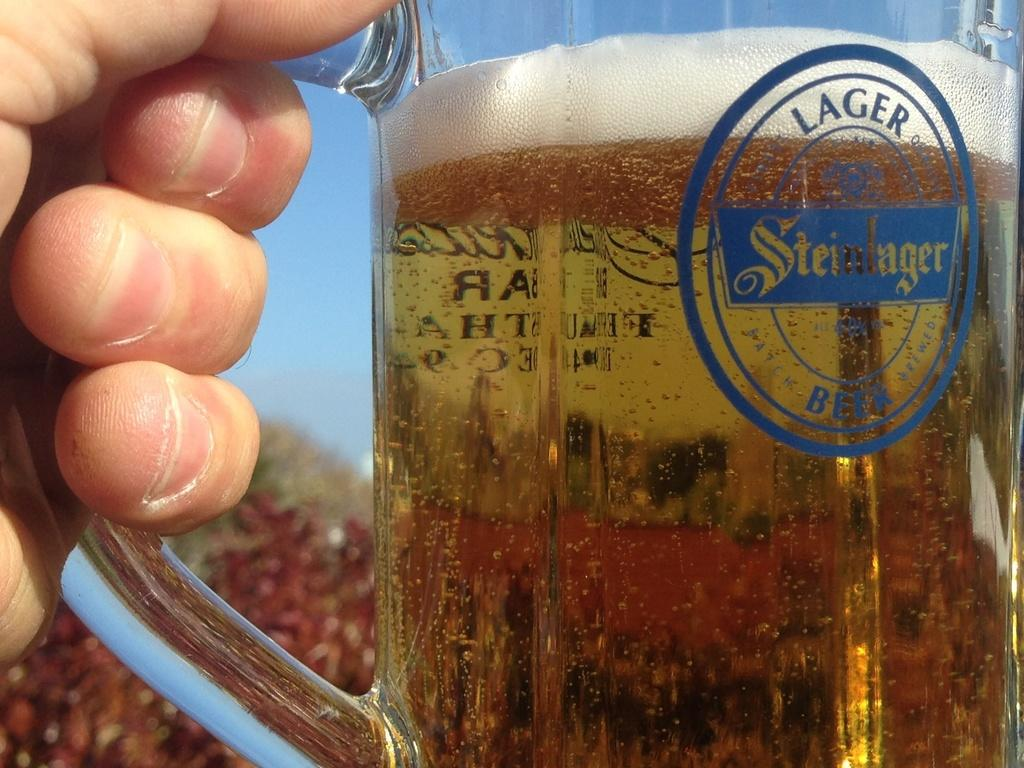What is the main subject in the foreground of the image? There is a person in the foreground of the image. What is the person holding in the image? The person is holding a glass. What is inside the glass? There is a drink in the glass. What can be seen in the background of the image? There are plants and the sky visible in the background of the image. Where is the kettle located in the image? There is no kettle present in the image. What type of ornament is hanging from the plants in the background? There is no ornament hanging from the plants in the background; only plants and the sky are visible. 